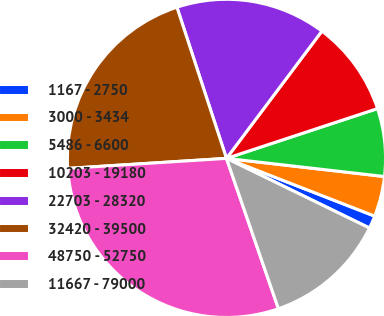Convert chart. <chart><loc_0><loc_0><loc_500><loc_500><pie_chart><fcel>1167 - 2750<fcel>3000 - 3434<fcel>5486 - 6600<fcel>10203 - 19180<fcel>22703 - 28320<fcel>32420 - 39500<fcel>48750 - 52750<fcel>11667 - 79000<nl><fcel>1.3%<fcel>4.09%<fcel>6.89%<fcel>9.69%<fcel>15.28%<fcel>20.96%<fcel>29.29%<fcel>12.49%<nl></chart> 